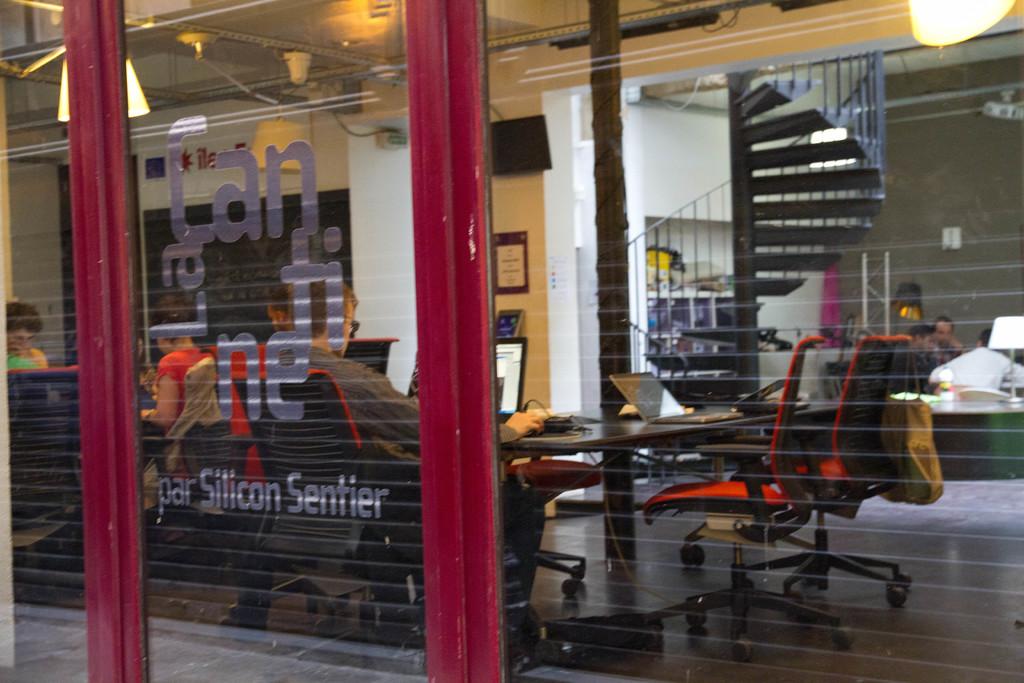What business is this?
Offer a terse response. Lan. 